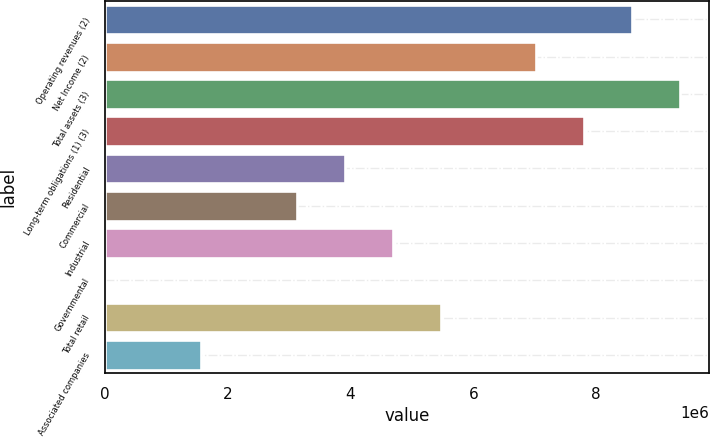<chart> <loc_0><loc_0><loc_500><loc_500><bar_chart><fcel>Operating revenues (2)<fcel>Net Income (2)<fcel>Total assets (3)<fcel>Long-term obligations (1) (3)<fcel>Residential<fcel>Commercial<fcel>Industrial<fcel>Governmental<fcel>Total retail<fcel>Associated companies<nl><fcel>8.59044e+06<fcel>7.02855e+06<fcel>9.37139e+06<fcel>7.8095e+06<fcel>3.90477e+06<fcel>3.12382e+06<fcel>4.68571e+06<fcel>41<fcel>5.46666e+06<fcel>1.56193e+06<nl></chart> 